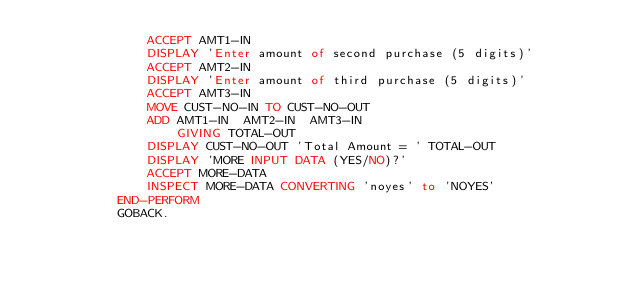Convert code to text. <code><loc_0><loc_0><loc_500><loc_500><_COBOL_>               ACCEPT AMT1-IN
               DISPLAY 'Enter amount of second purchase (5 digits)'
               ACCEPT AMT2-IN
               DISPLAY 'Enter amount of third purchase (5 digits)'
               ACCEPT AMT3-IN
               MOVE CUST-NO-IN TO CUST-NO-OUT
               ADD AMT1-IN  AMT2-IN  AMT3-IN
                   GIVING TOTAL-OUT
               DISPLAY CUST-NO-OUT 'Total Amount = ' TOTAL-OUT
               DISPLAY 'MORE INPUT DATA (YES/NO)?'
               ACCEPT MORE-DATA
               INSPECT MORE-DATA CONVERTING 'noyes' to 'NOYES'
           END-PERFORM
           GOBACK.
</code> 